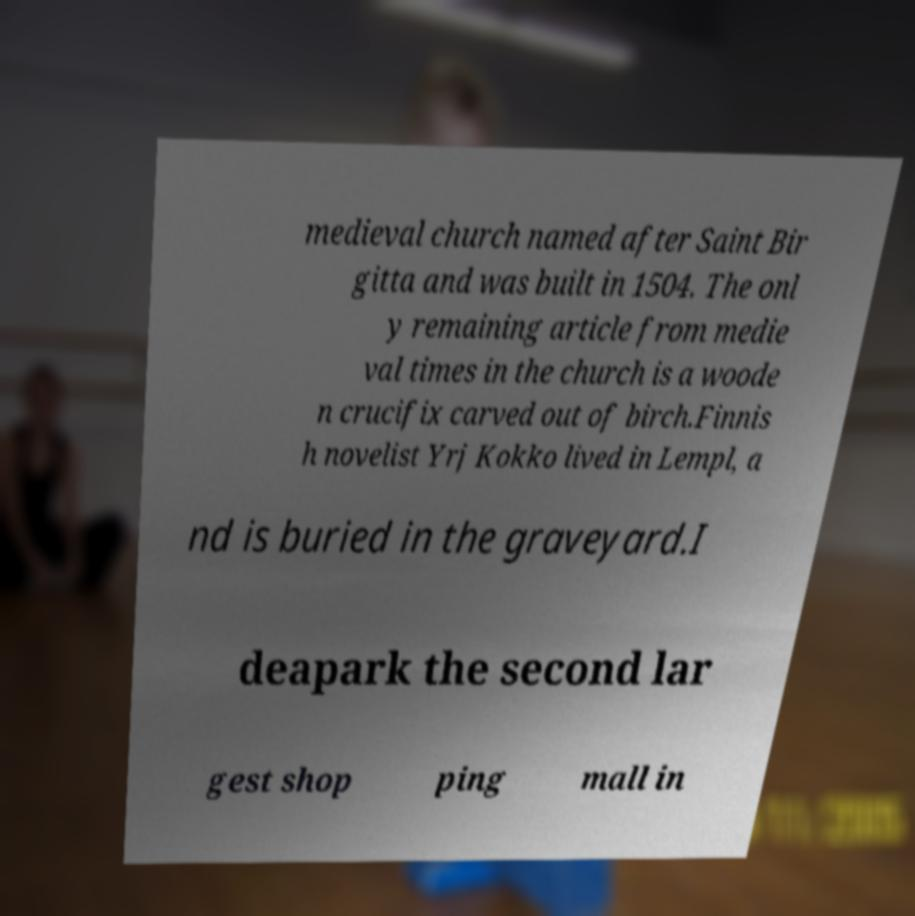What messages or text are displayed in this image? I need them in a readable, typed format. medieval church named after Saint Bir gitta and was built in 1504. The onl y remaining article from medie val times in the church is a woode n crucifix carved out of birch.Finnis h novelist Yrj Kokko lived in Lempl, a nd is buried in the graveyard.I deapark the second lar gest shop ping mall in 